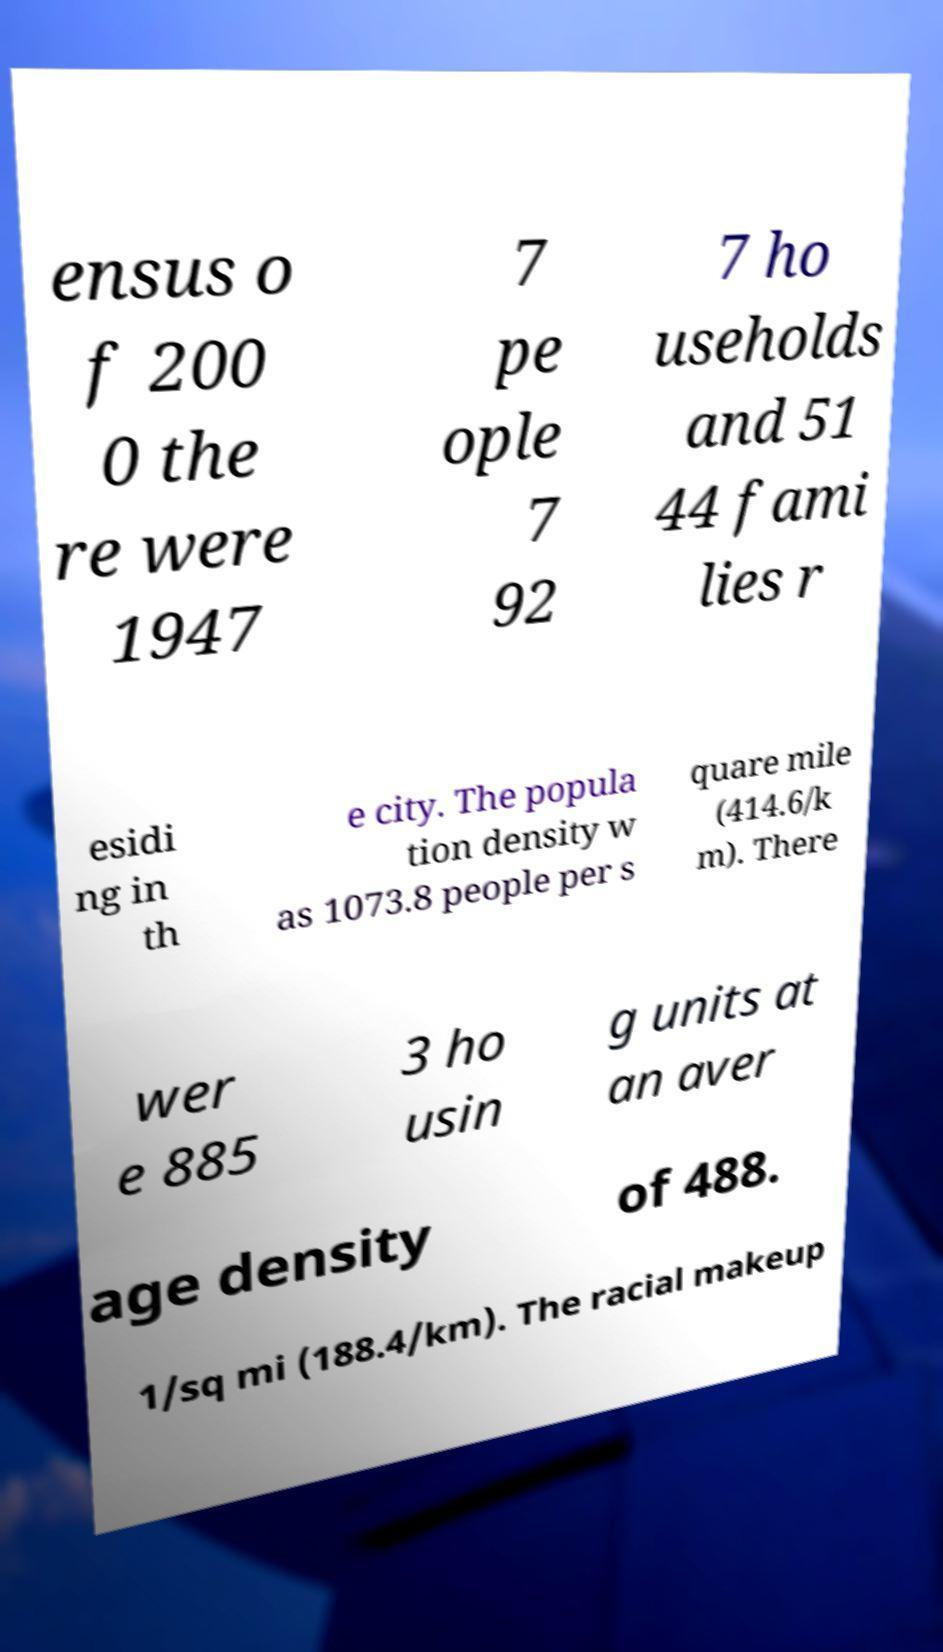Could you extract and type out the text from this image? ensus o f 200 0 the re were 1947 7 pe ople 7 92 7 ho useholds and 51 44 fami lies r esidi ng in th e city. The popula tion density w as 1073.8 people per s quare mile (414.6/k m). There wer e 885 3 ho usin g units at an aver age density of 488. 1/sq mi (188.4/km). The racial makeup 